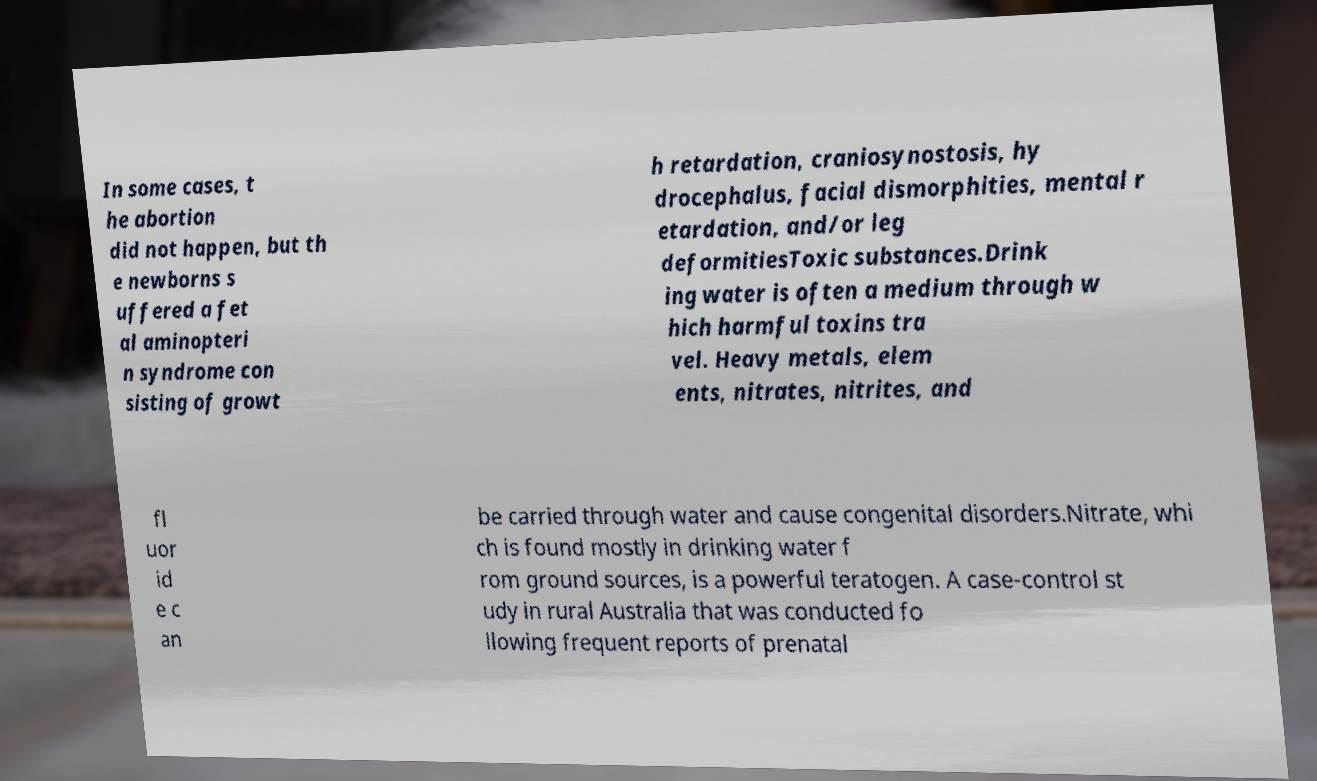What messages or text are displayed in this image? I need them in a readable, typed format. In some cases, t he abortion did not happen, but th e newborns s uffered a fet al aminopteri n syndrome con sisting of growt h retardation, craniosynostosis, hy drocephalus, facial dismorphities, mental r etardation, and/or leg deformitiesToxic substances.Drink ing water is often a medium through w hich harmful toxins tra vel. Heavy metals, elem ents, nitrates, nitrites, and fl uor id e c an be carried through water and cause congenital disorders.Nitrate, whi ch is found mostly in drinking water f rom ground sources, is a powerful teratogen. A case-control st udy in rural Australia that was conducted fo llowing frequent reports of prenatal 